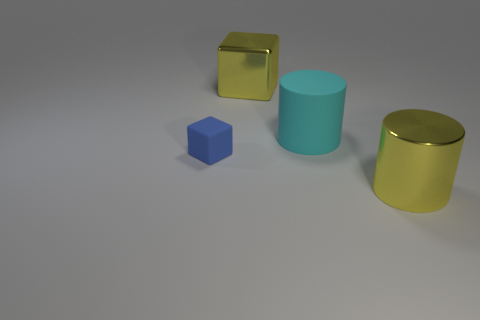Is the small matte block the same color as the large rubber thing?
Give a very brief answer. No. There is a yellow block that is the same size as the cyan matte cylinder; what material is it?
Your response must be concise. Metal. Is the material of the cyan cylinder the same as the tiny blue cube?
Your answer should be very brief. Yes. What number of other big cylinders are the same material as the cyan cylinder?
Your answer should be very brief. 0. What number of objects are large yellow things in front of the cyan object or cubes that are right of the small cube?
Offer a very short reply. 2. Are there more large cyan things that are left of the small blue matte cube than small cubes that are behind the large cyan rubber thing?
Provide a succinct answer. No. The big shiny thing that is in front of the big shiny cube is what color?
Make the answer very short. Yellow. Are there any other blue rubber things that have the same shape as the small blue rubber thing?
Offer a very short reply. No. What number of cyan objects are either big metal cylinders or matte cylinders?
Provide a succinct answer. 1. Is there another yellow block that has the same size as the rubber cube?
Give a very brief answer. No. 